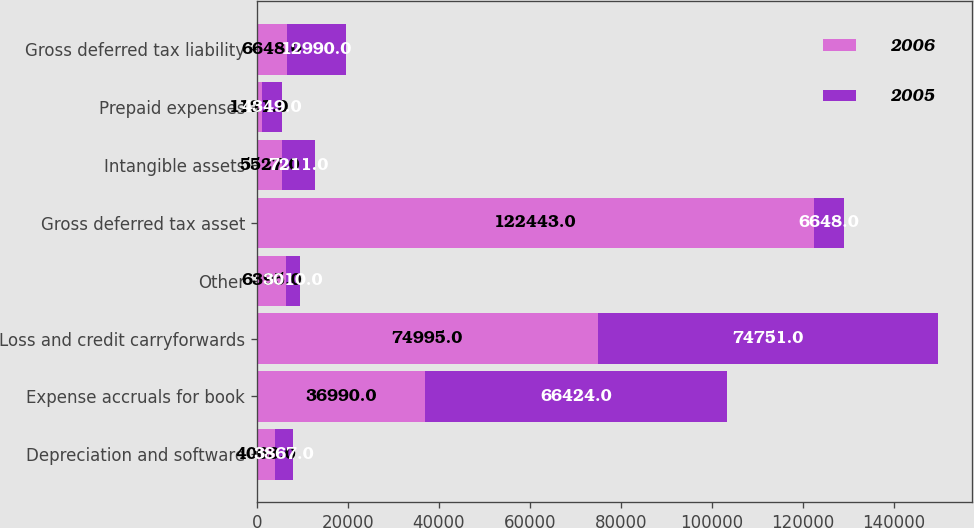Convert chart. <chart><loc_0><loc_0><loc_500><loc_500><stacked_bar_chart><ecel><fcel>Depreciation and software<fcel>Expense accruals for book<fcel>Loss and credit carryforwards<fcel>Other<fcel>Gross deferred tax asset<fcel>Intangible assets<fcel>Prepaid expenses<fcel>Gross deferred tax liability<nl><fcel>2006<fcel>4063<fcel>36990<fcel>74995<fcel>6395<fcel>122443<fcel>5527<fcel>1121<fcel>6648<nl><fcel>2005<fcel>3867<fcel>66424<fcel>74751<fcel>3010<fcel>6648<fcel>7211<fcel>4349<fcel>12990<nl></chart> 